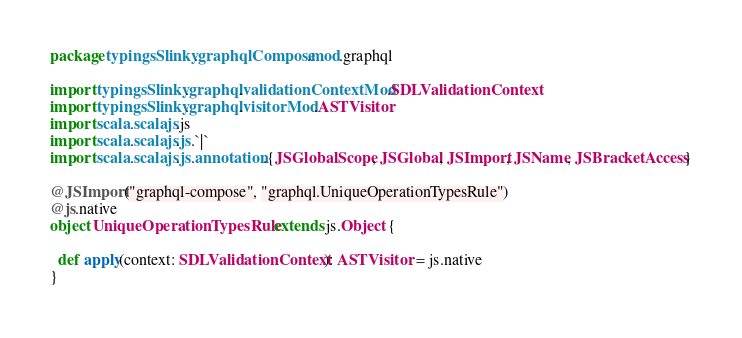<code> <loc_0><loc_0><loc_500><loc_500><_Scala_>package typingsSlinky.graphqlCompose.mod.graphql

import typingsSlinky.graphql.validationContextMod.SDLValidationContext
import typingsSlinky.graphql.visitorMod.ASTVisitor
import scala.scalajs.js
import scala.scalajs.js.`|`
import scala.scalajs.js.annotation.{JSGlobalScope, JSGlobal, JSImport, JSName, JSBracketAccess}

@JSImport("graphql-compose", "graphql.UniqueOperationTypesRule")
@js.native
object UniqueOperationTypesRule extends js.Object {
  
  def apply(context: SDLValidationContext): ASTVisitor = js.native
}
</code> 